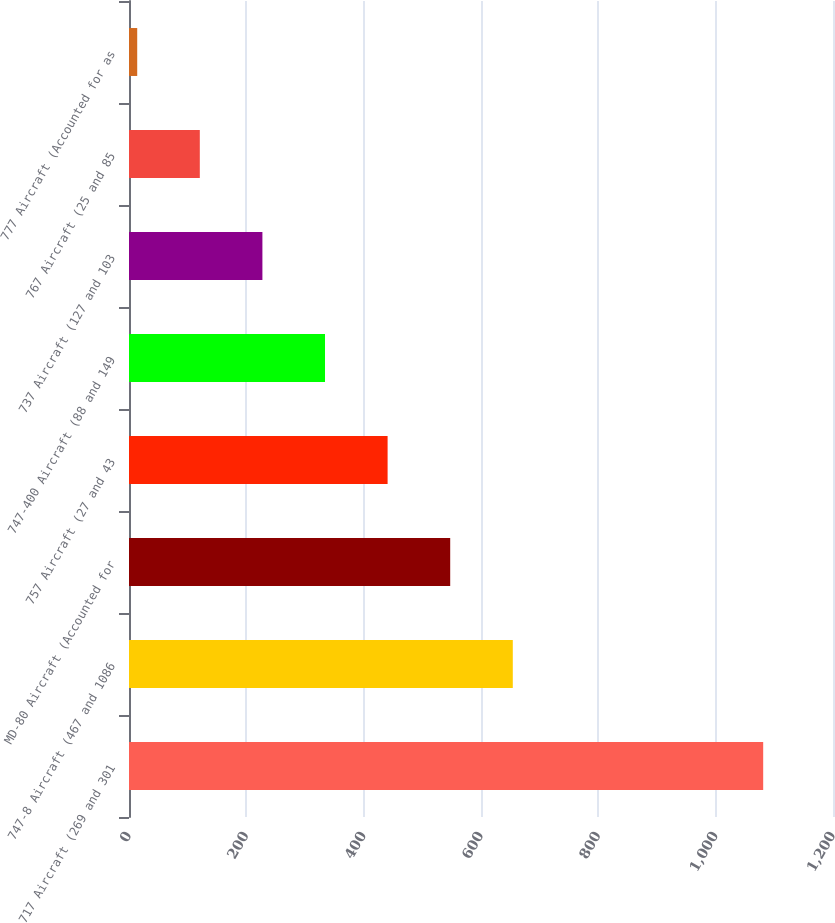<chart> <loc_0><loc_0><loc_500><loc_500><bar_chart><fcel>717 Aircraft (269 and 301<fcel>747-8 Aircraft (467 and 1086<fcel>MD-80 Aircraft (Accounted for<fcel>757 Aircraft (27 and 43<fcel>747-400 Aircraft (88 and 149<fcel>737 Aircraft (127 and 103<fcel>767 Aircraft (25 and 85<fcel>777 Aircraft (Accounted for as<nl><fcel>1081<fcel>654.2<fcel>547.5<fcel>440.8<fcel>334.1<fcel>227.4<fcel>120.7<fcel>14<nl></chart> 